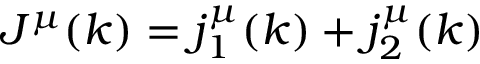Convert formula to latex. <formula><loc_0><loc_0><loc_500><loc_500>J ^ { \mu } ( k ) = j _ { 1 } ^ { \mu } ( k ) + j _ { 2 } ^ { \mu } ( k )</formula> 